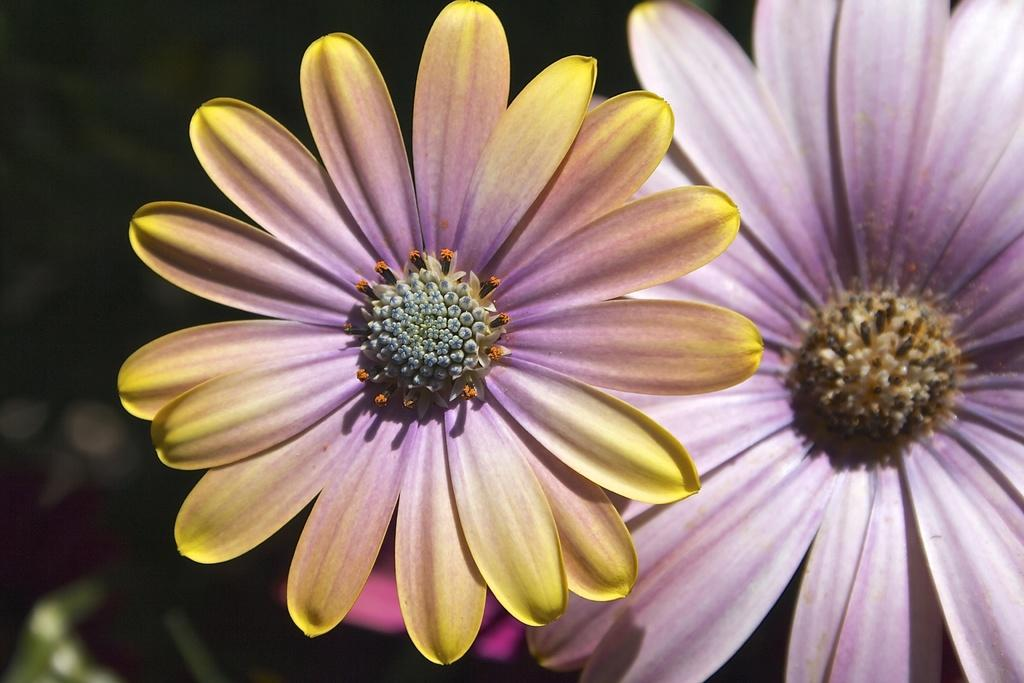What type of living organisms can be seen in the image? There are flowers in the image. What type of support is the oven using to stay upright in the image? There is no oven present in the image, as it only features flowers. Is there any snow visible in the image? There is no snow present in the image, as it only features flowers. 